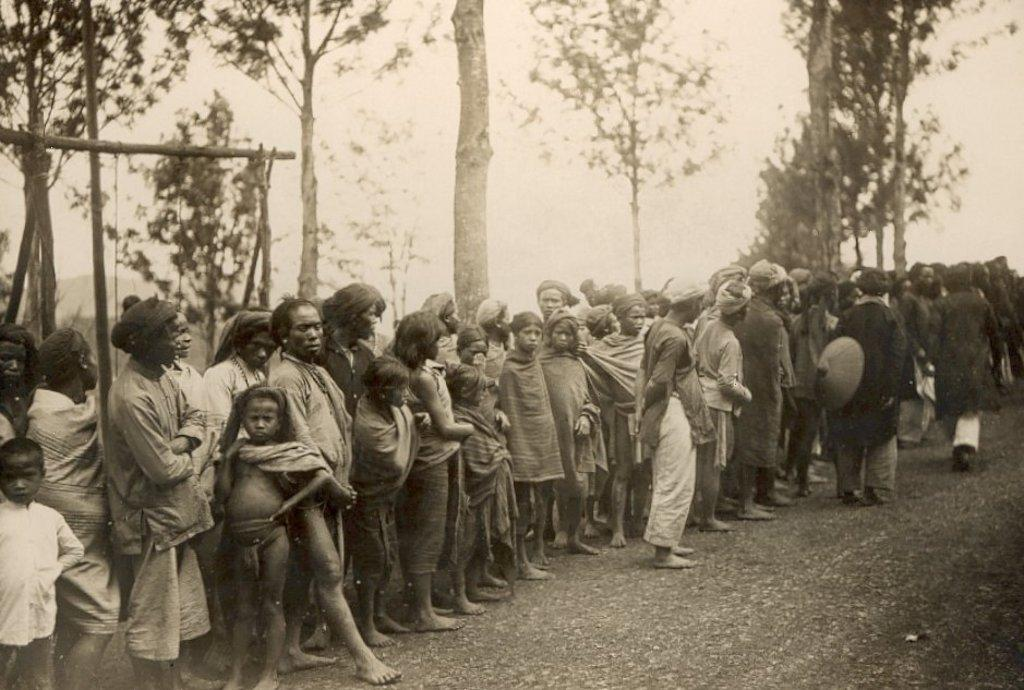What are the people in the image doing? There is a group of people standing in the image, and two people are walking. What can be seen in the background of the image? Trees are visible at the back of the image, and the sky is visible at the top. What is visible at the bottom of the image? The ground is visible at the bottom of the image. What type of voice can be heard coming from the trees in the image? There is no voice coming from the trees in the image, as trees do not produce sounds. 